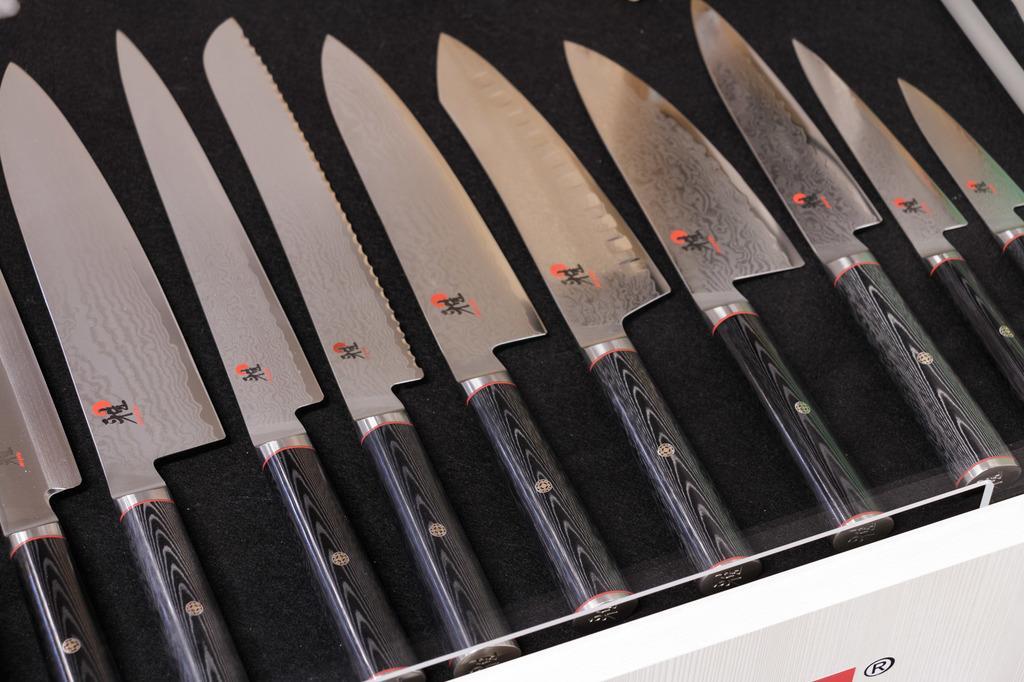How would you summarize this image in a sentence or two? In the picture there are many knives of different shapes are kept on a table. 